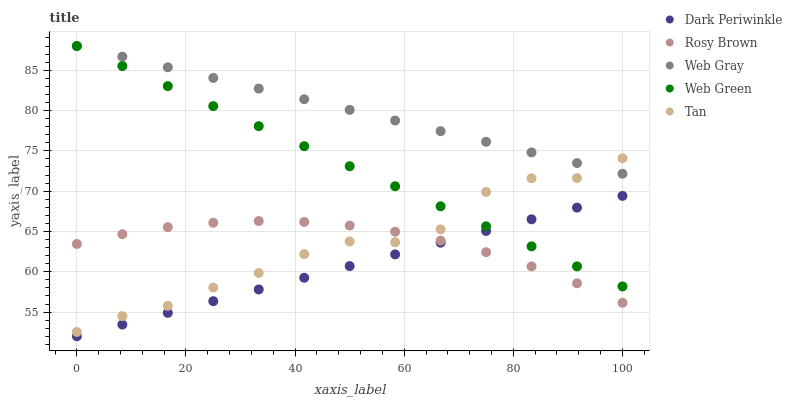Does Dark Periwinkle have the minimum area under the curve?
Answer yes or no. Yes. Does Web Gray have the maximum area under the curve?
Answer yes or no. Yes. Does Rosy Brown have the minimum area under the curve?
Answer yes or no. No. Does Rosy Brown have the maximum area under the curve?
Answer yes or no. No. Is Web Green the smoothest?
Answer yes or no. Yes. Is Tan the roughest?
Answer yes or no. Yes. Is Rosy Brown the smoothest?
Answer yes or no. No. Is Rosy Brown the roughest?
Answer yes or no. No. Does Dark Periwinkle have the lowest value?
Answer yes or no. Yes. Does Rosy Brown have the lowest value?
Answer yes or no. No. Does Web Green have the highest value?
Answer yes or no. Yes. Does Rosy Brown have the highest value?
Answer yes or no. No. Is Dark Periwinkle less than Web Gray?
Answer yes or no. Yes. Is Web Gray greater than Rosy Brown?
Answer yes or no. Yes. Does Rosy Brown intersect Tan?
Answer yes or no. Yes. Is Rosy Brown less than Tan?
Answer yes or no. No. Is Rosy Brown greater than Tan?
Answer yes or no. No. Does Dark Periwinkle intersect Web Gray?
Answer yes or no. No. 